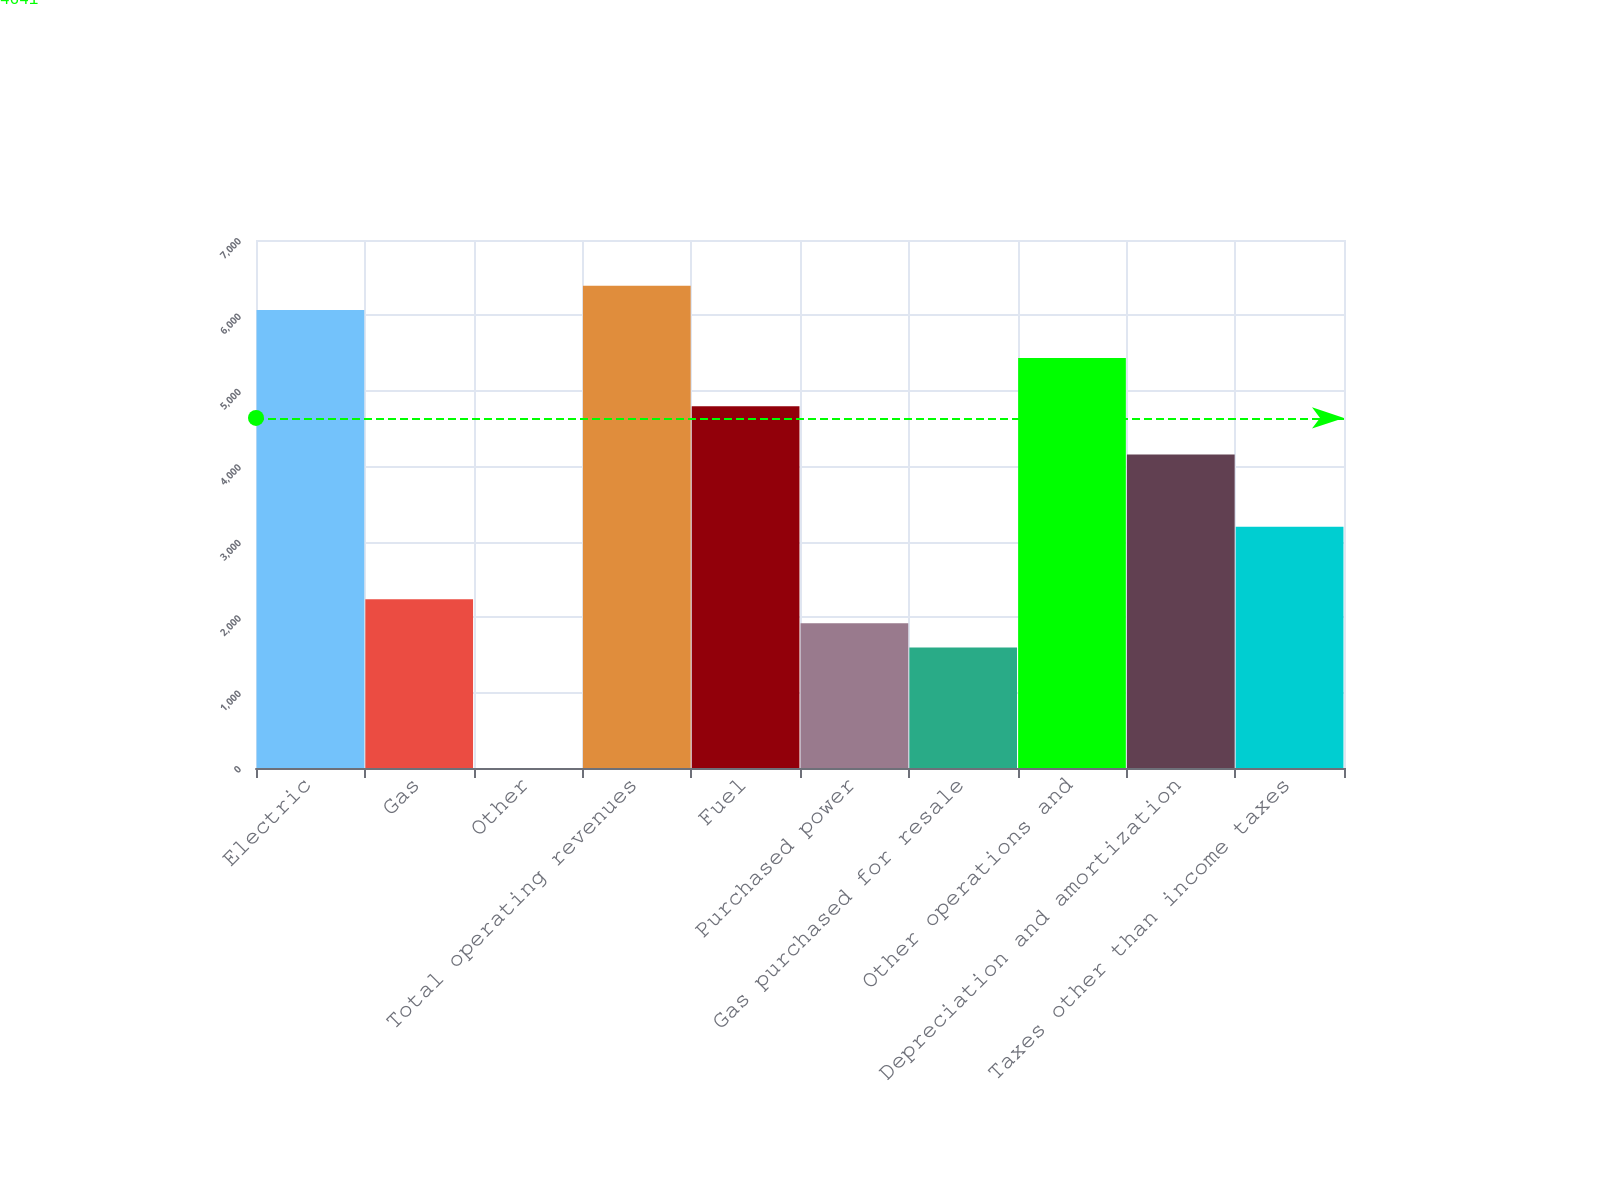<chart> <loc_0><loc_0><loc_500><loc_500><bar_chart><fcel>Electric<fcel>Gas<fcel>Other<fcel>Total operating revenues<fcel>Fuel<fcel>Purchased power<fcel>Gas purchased for resale<fcel>Other operations and<fcel>Depreciation and amortization<fcel>Taxes other than income taxes<nl><fcel>6073.4<fcel>2238.2<fcel>1<fcel>6393<fcel>4795<fcel>1918.6<fcel>1599<fcel>5434.2<fcel>4155.8<fcel>3197<nl></chart> 